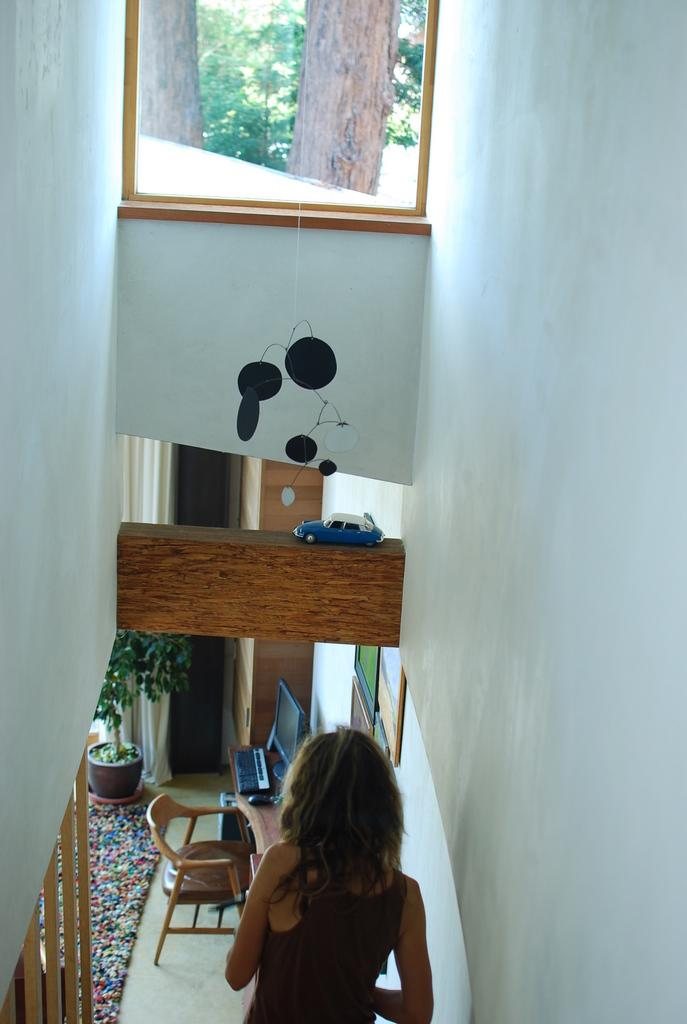What can be seen through the window in the image? The facts provided do not specify what can be seen through the window. What type of toy is present in the image? There is a toy car in the image. Who is present in the image? There is a woman in the image. What type of furniture is in the image? There is a chair in the image. What surface might the woman be using for work or study? There is a desktop in the image. What type of plant is in the image? The facts provided do not specify the type of plant in the image. What is the chance of the toy car falling off the roof in the image? There is no roof present in the image, and therefore no chance of the toy car falling off a roof. 